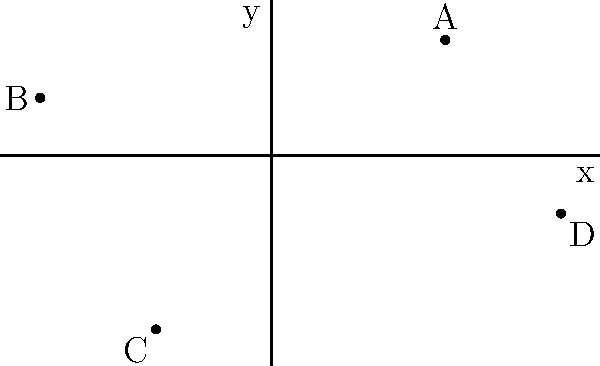Given the points A(3,2), B(-4,1), C(-2,-3), and D(5,-1) plotted on the coordinate plane, determine the quadrant in which each point lies. Then, calculate the total number of points in the third quadrant. To solve this problem, let's follow these steps:

1. Recall the quadrant rules:
   - Quadrant I: Both x and y are positive (+,+)
   - Quadrant II: x is negative, y is positive (-,+)
   - Quadrant III: Both x and y are negative (-,-)
   - Quadrant IV: x is positive, y is negative (+,-)

2. Analyze each point:

   A(3,2):
   - x = 3 (positive)
   - y = 2 (positive)
   - Therefore, A is in Quadrant I

   B(-4,1):
   - x = -4 (negative)
   - y = 1 (positive)
   - Therefore, B is in Quadrant II

   C(-2,-3):
   - x = -2 (negative)
   - y = -3 (negative)
   - Therefore, C is in Quadrant III

   D(5,-1):
   - x = 5 (positive)
   - y = -1 (negative)
   - Therefore, D is in Quadrant IV

3. Count the number of points in Quadrant III:
   Only point C is in Quadrant III.

Therefore, the total number of points in the third quadrant is 1.
Answer: 1 